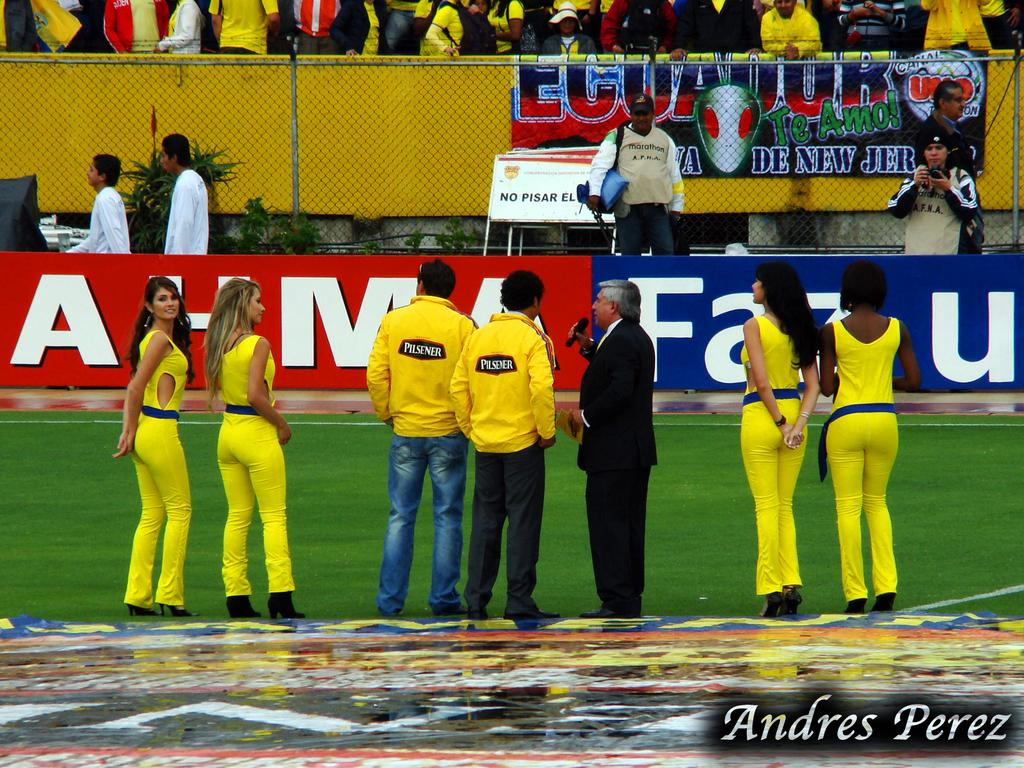What is the main setting of the image? The main setting of the image is a stadium. What are the people in the image doing? The people are standing on the ground of the stadium. What can be seen in the background of the image? There is an audience in the background. What is the central feature of the image? There is a fencing with a net at the center of the image. What month is it in the image? The month cannot be determined from the image, as there is no information about the date or time of year. Is there a whip visible in the image? No, there is no whip present in the image. 